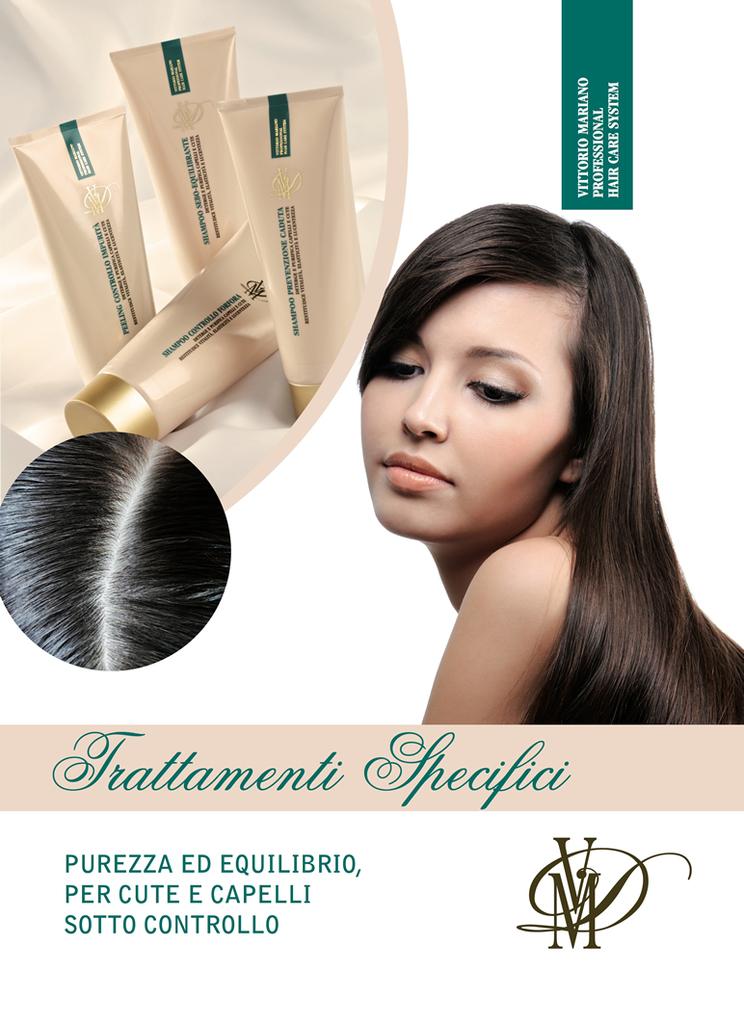What's the brand?
Ensure brevity in your answer.  Trattamenti specifici. What language is this in?
Ensure brevity in your answer.  Unanswerable. 